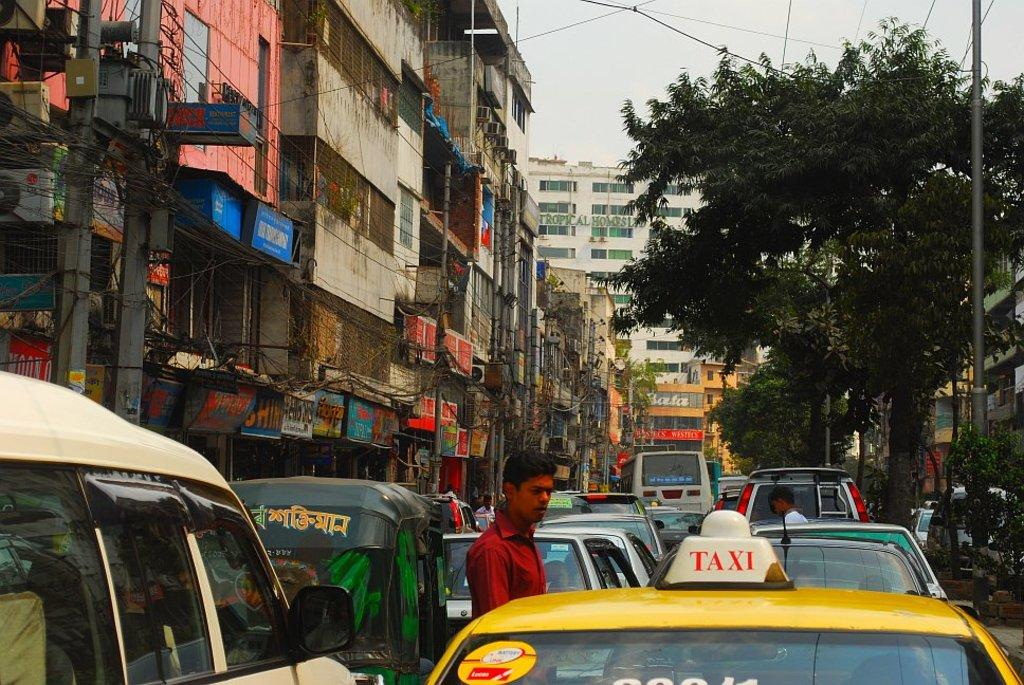Provide a one-sentence caption for the provided image. Taxi stuck in traffic driving through city traffic. 